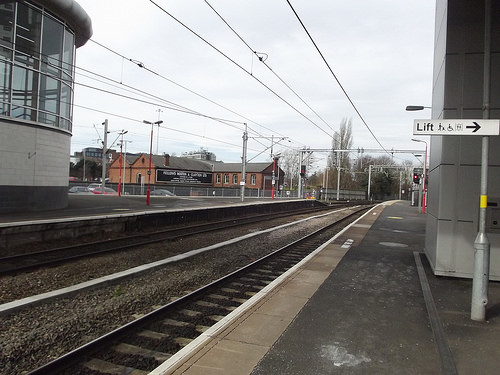<image>
Is the track under the power lines? Yes. The track is positioned underneath the power lines, with the power lines above it in the vertical space. 